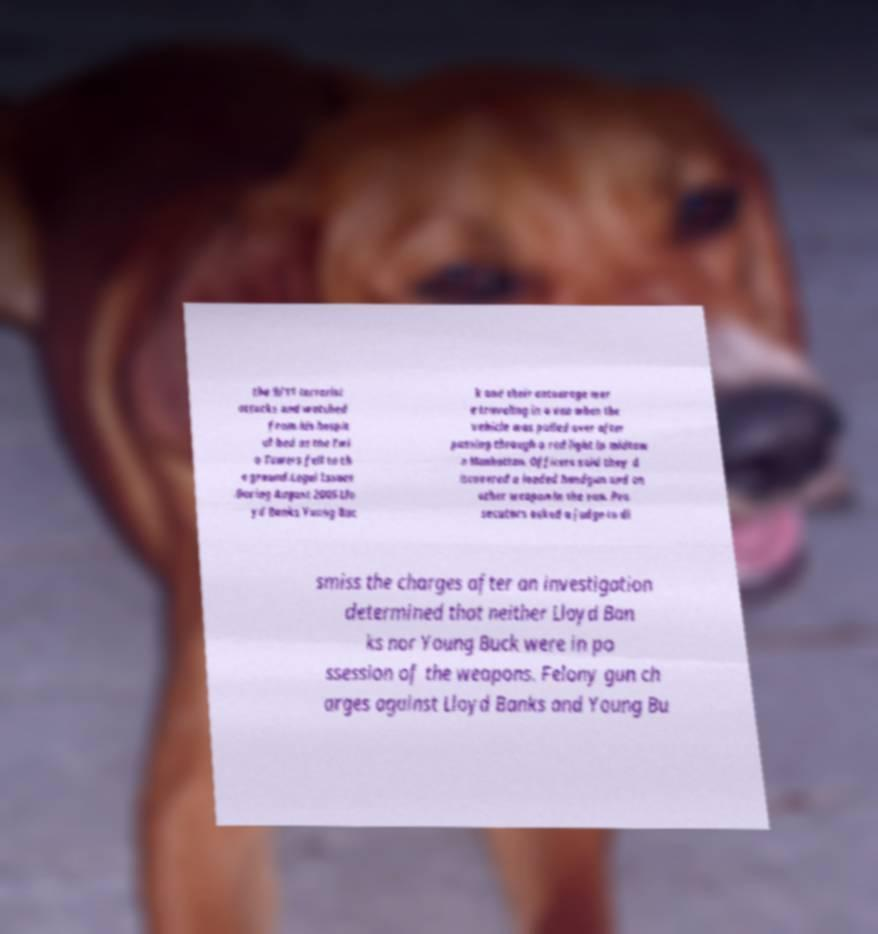Please read and relay the text visible in this image. What does it say? the 9/11 terrorist attacks and watched from his hospit al bed as the Twi n Towers fell to th e ground.Legal Issues .During August 2005 Llo yd Banks Young Buc k and their entourage wer e traveling in a van when the vehicle was pulled over after passing through a red light in midtow n Manhattan. Officers said they d iscovered a loaded handgun and an other weapon in the van. Pro secutors asked a judge to di smiss the charges after an investigation determined that neither Lloyd Ban ks nor Young Buck were in po ssession of the weapons. Felony gun ch arges against Lloyd Banks and Young Bu 